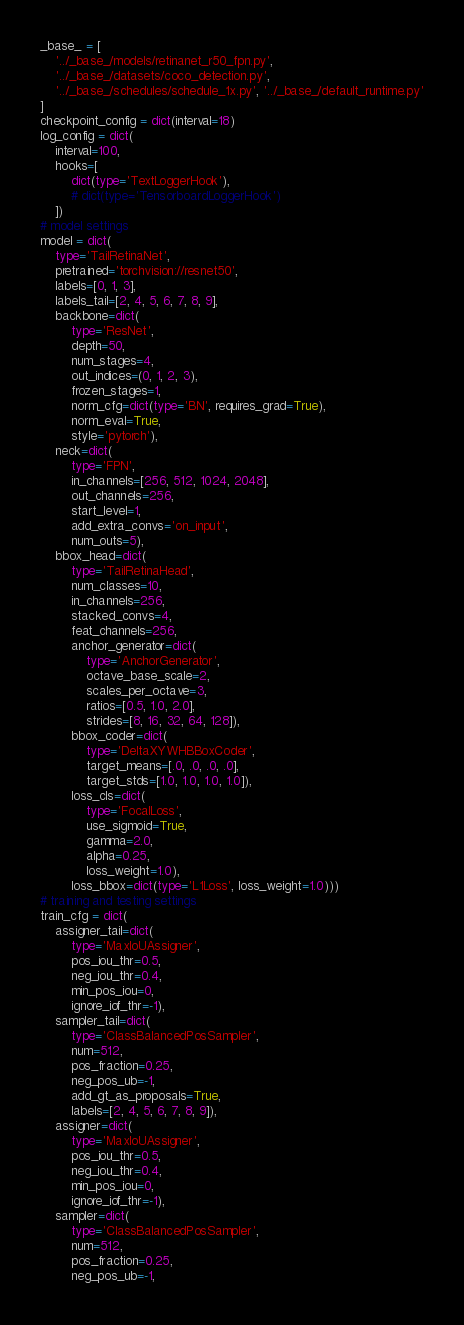Convert code to text. <code><loc_0><loc_0><loc_500><loc_500><_Python_>_base_ = [
    '../_base_/models/retinanet_r50_fpn.py',
    '../_base_/datasets/coco_detection.py',
    '../_base_/schedules/schedule_1x.py', '../_base_/default_runtime.py'
]
checkpoint_config = dict(interval=18)
log_config = dict(
    interval=100,
    hooks=[
        dict(type='TextLoggerHook'),
        # dict(type='TensorboardLoggerHook')
    ])
# model settings
model = dict(
    type='TailRetinaNet',
    pretrained='torchvision://resnet50',
    labels=[0, 1, 3],
    labels_tail=[2, 4, 5, 6, 7, 8, 9],
    backbone=dict(
        type='ResNet',
        depth=50,
        num_stages=4,
        out_indices=(0, 1, 2, 3),
        frozen_stages=1,
        norm_cfg=dict(type='BN', requires_grad=True),
        norm_eval=True,
        style='pytorch'),
    neck=dict(
        type='FPN',
        in_channels=[256, 512, 1024, 2048],
        out_channels=256,
        start_level=1,
        add_extra_convs='on_input',
        num_outs=5),
    bbox_head=dict(
        type='TailRetinaHead',
        num_classes=10,
        in_channels=256,
        stacked_convs=4,
        feat_channels=256,
        anchor_generator=dict(
            type='AnchorGenerator',
            octave_base_scale=2,
            scales_per_octave=3,
            ratios=[0.5, 1.0, 2.0],
            strides=[8, 16, 32, 64, 128]),
        bbox_coder=dict(
            type='DeltaXYWHBBoxCoder',
            target_means=[.0, .0, .0, .0],
            target_stds=[1.0, 1.0, 1.0, 1.0]),
        loss_cls=dict(
            type='FocalLoss',
            use_sigmoid=True,
            gamma=2.0,
            alpha=0.25,
            loss_weight=1.0),
        loss_bbox=dict(type='L1Loss', loss_weight=1.0)))
# training and testing settings
train_cfg = dict(
    assigner_tail=dict(
        type='MaxIoUAssigner',
        pos_iou_thr=0.5,
        neg_iou_thr=0.4,
        min_pos_iou=0,
        ignore_iof_thr=-1),
    sampler_tail=dict(
        type='ClassBalancedPosSampler',
        num=512,
        pos_fraction=0.25,
        neg_pos_ub=-1,
        add_gt_as_proposals=True,
        labels=[2, 4, 5, 6, 7, 8, 9]),
    assigner=dict(
        type='MaxIoUAssigner',
        pos_iou_thr=0.5,
        neg_iou_thr=0.4,
        min_pos_iou=0,
        ignore_iof_thr=-1),
    sampler=dict(
        type='ClassBalancedPosSampler',
        num=512,
        pos_fraction=0.25,
        neg_pos_ub=-1,</code> 